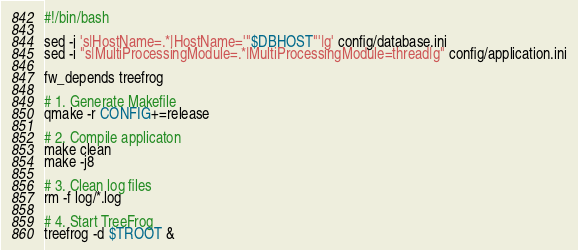<code> <loc_0><loc_0><loc_500><loc_500><_Bash_>#!/bin/bash

sed -i 's|HostName=.*|HostName='"$DBHOST"'|g' config/database.ini
sed -i "s|MultiProcessingModule=.*|MultiProcessingModule=thread|g" config/application.ini

fw_depends treefrog

# 1. Generate Makefile
qmake -r CONFIG+=release

# 2. Compile applicaton
make clean
make -j8

# 3. Clean log files
rm -f log/*.log

# 4. Start TreeFrog
treefrog -d $TROOT &
</code> 